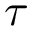<formula> <loc_0><loc_0><loc_500><loc_500>\tau</formula> 